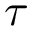<formula> <loc_0><loc_0><loc_500><loc_500>\tau</formula> 